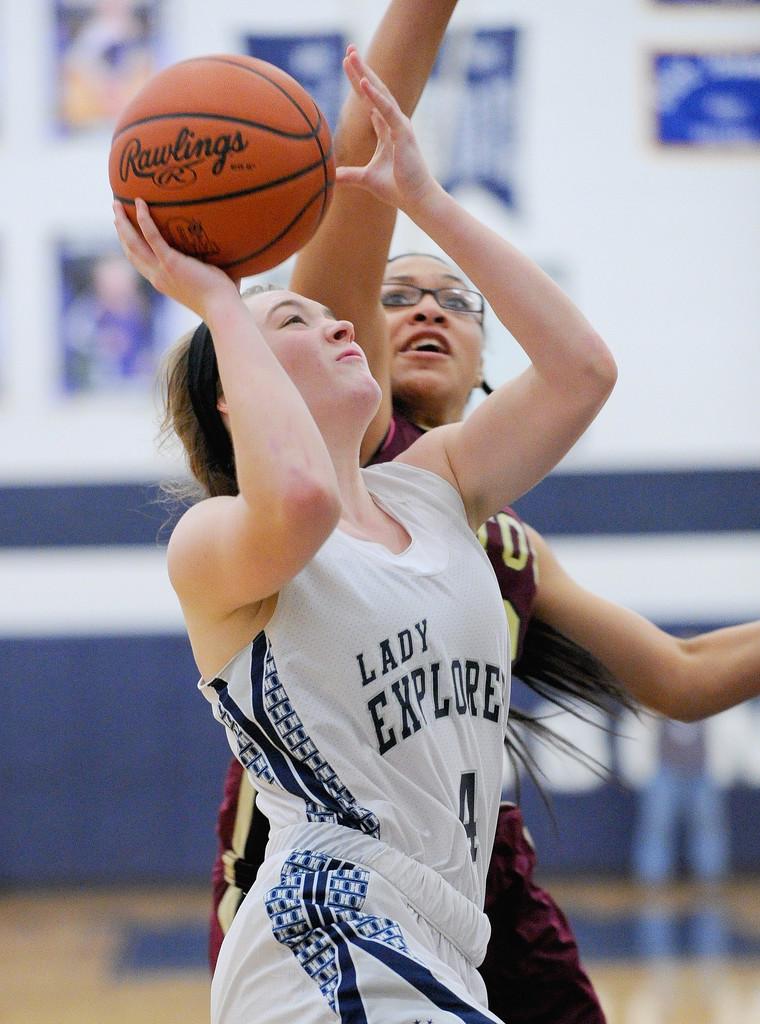What brand of basketball does the player have?
Make the answer very short. Rawlings. 